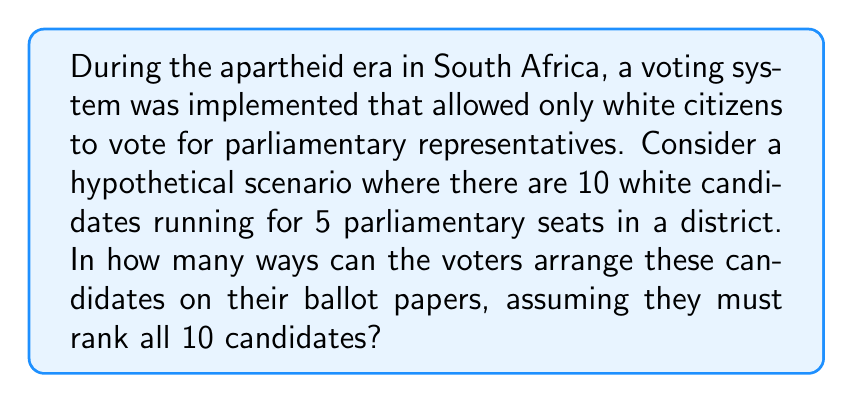Help me with this question. To solve this problem, we need to consider the concept of permutations in Abstract Algebra. 

1) In this scenario, we are arranging 10 candidates in a specific order. This is a perfect example of a permutation.

2) The number of permutations of n distinct objects is given by n!

3) In this case, n = 10 (the number of candidates)

4) Therefore, the number of ways to arrange these candidates on a ballot paper is:

   $$10! = 10 \times 9 \times 8 \times 7 \times 6 \times 5 \times 4 \times 3 \times 2 \times 1$$

5) Let's calculate this:
   
   $$10! = 3,628,800$$

6) It's important to note that this voting system, which excluded the majority of South Africa's population based on race, was a reflection of the apartheid policies that were in place until the early 1990s. The German immigrant descendants, as part of the white minority, would have been among those allowed to participate in this restrictive voting system.
Answer: There are 3,628,800 possible ways to arrange the 10 candidates on the ballot papers. 